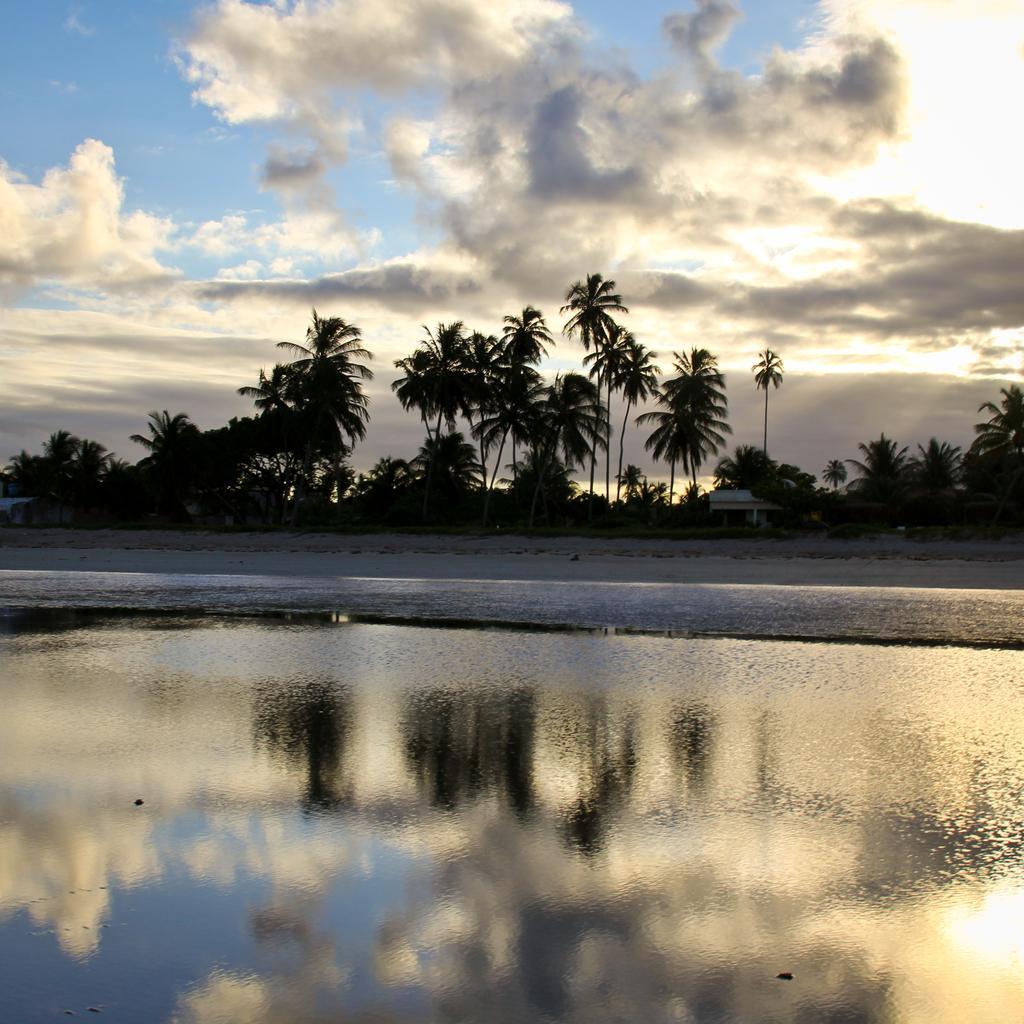Please provide a concise description of this image. In this image in the foreground there is water body. In the background there are trees, buildings. The sky is cloudy. 